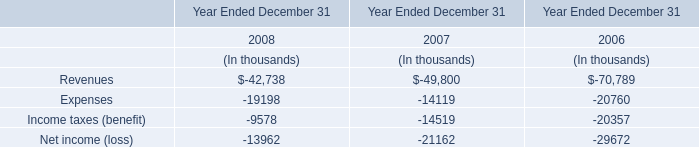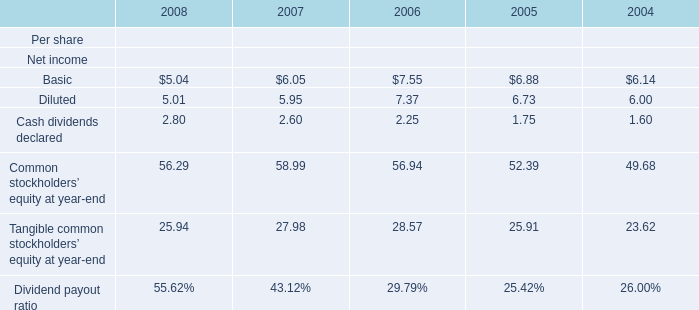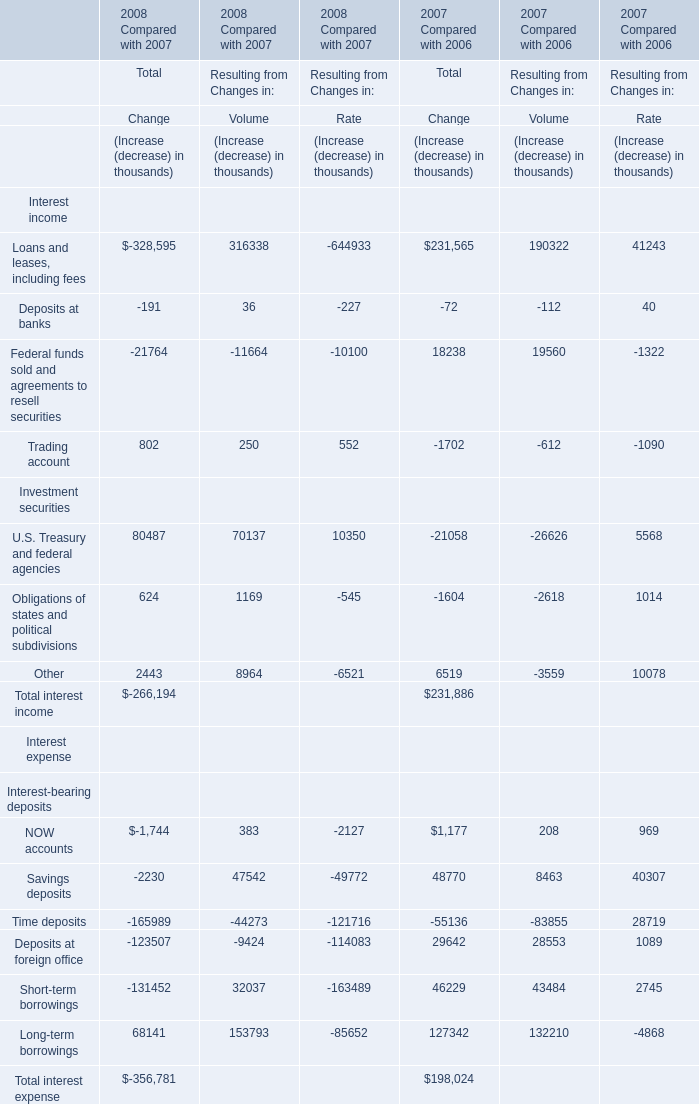What's the sum of the Cash dividends declared for Net income in the years where Long-term borrowings for Volume for Resulting from Changes in is positive? 
Computations: (2.80 + 2.60)
Answer: 5.4. 